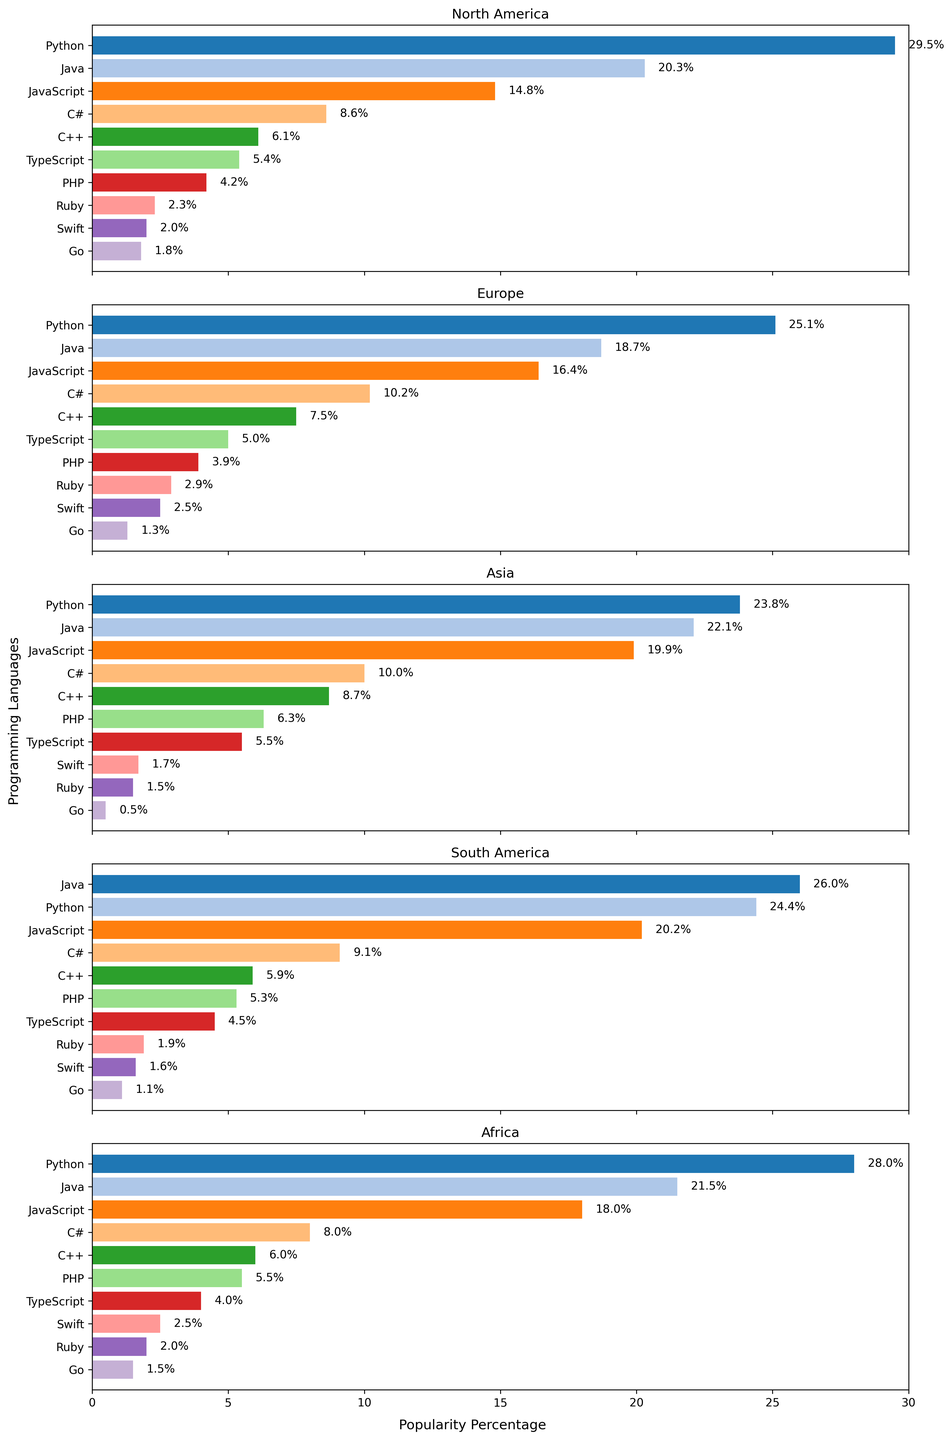Which region has the highest percentage of Python usage? Observe the bar chart for Python usage in all regions and compare the heights of the bars. The tallest bar corresponds to North America with 29.5%.
Answer: North America Which programming language is more popular in Asia, C++ or JavaScript? Compare the heights of the bars for C++ and JavaScript in the Asia region. JavaScript has a higher percentage (19.9%) compared to C++ (8.7%).
Answer: JavaScript Which region has the lowest percentage of Ruby usage? Compare the heights of the Ruby bars across all regions. Asia has the lowest percentage at 1.5%.
Answer: Asia What is the total percentage of Java usage across all regions? Add the Java usage percentages from each region: North America (20.3), Europe (18.7), Asia (22.1), South America (26.0), and Africa (21.5). Total: 20.3 + 18.7 + 22.1 + 26.0 + 21.5 = 108.6%.
Answer: 108.6 Is Python more popular than Java in Africa? Compare the heights of the Python and Java bars in the Africa region. Python has a higher percentage (28.0%) compared to Java (21.5%).
Answer: Yes Which region has the greatest difference in popularity between Python and JavaScript? Calculate the difference between Python and JavaScript for each region:
  North America: 29.5 - 14.8 = 14.7
  Europe: 25.1 - 16.4 = 8.7
  Asia: 23.8 - 19.9 = 3.9
  South America: 24.4 - 20.2 = 4.2
  Africa: 28.0 - 18.0 = 10.0
The greatest difference is in North America at 14.7.
Answer: North America Which programming language has the closest percentages in South America and Africa? Check the bars for each programming language for similarity in South America and Africa:
  Java: 26.0 vs. 21.5
  Python: 24.4 vs. 28.0
  JavaScript: 20.2 vs. 18.0
  C#: 9.1 vs. 8.0
  C++: 5.9 vs. 6.0
  PHP: 5.3 vs. 5.5
  TypeScript: 4.5 vs. 4.0
The closest percentages are for C++ (5.9 and 6.0).
Answer: C++ Which region has the highest diversity in programming languages by having the smallest range of usage percentages? The range is calculated as the difference between the highest and lowest percentages in each region:
  North America: 29.5 - 1.8 = 27.7
  Europe: 25.1 - 1.3 = 23.8
  Asia: 23.8 - 0.5 = 23.3
  South America: 26.0 - 1.1 = 24.9
  Africa: 28.0 - 1.5 = 26.5
The smallest range is for Asia at 23.3%.
Answer: Asia 